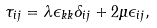<formula> <loc_0><loc_0><loc_500><loc_500>\tau _ { i j } = \lambda \epsilon _ { k k } \delta _ { i j } + 2 \mu \epsilon _ { i j } ,</formula> 